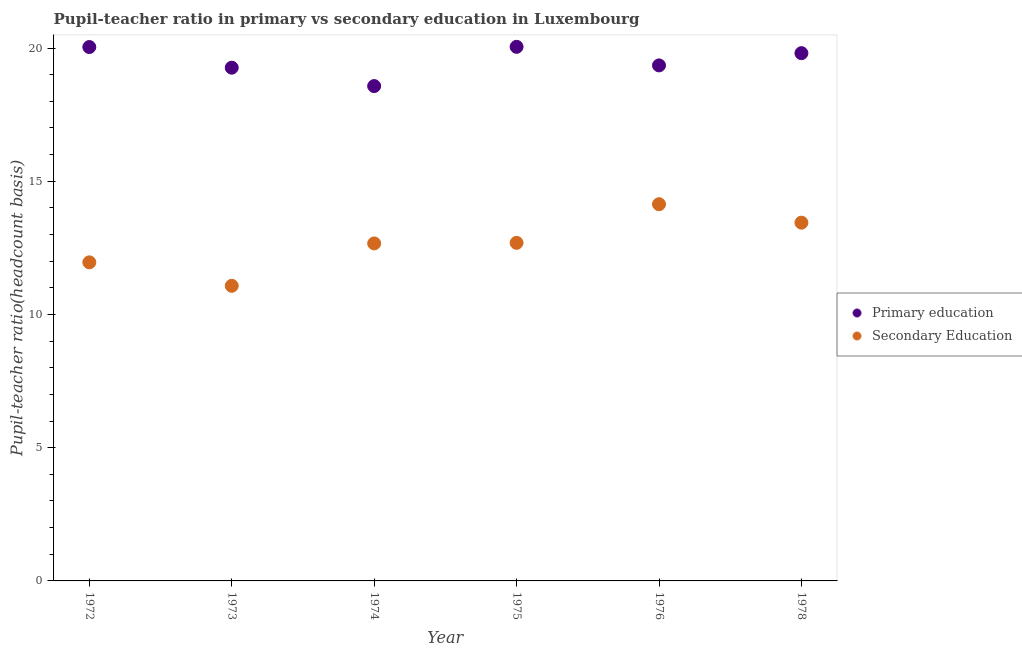Is the number of dotlines equal to the number of legend labels?
Provide a succinct answer. Yes. What is the pupil teacher ratio on secondary education in 1972?
Offer a very short reply. 11.96. Across all years, what is the maximum pupil teacher ratio on secondary education?
Ensure brevity in your answer.  14.14. Across all years, what is the minimum pupil-teacher ratio in primary education?
Offer a terse response. 18.57. In which year was the pupil teacher ratio on secondary education maximum?
Provide a succinct answer. 1976. In which year was the pupil-teacher ratio in primary education minimum?
Offer a terse response. 1974. What is the total pupil-teacher ratio in primary education in the graph?
Your answer should be very brief. 117.08. What is the difference between the pupil teacher ratio on secondary education in 1975 and that in 1976?
Offer a terse response. -1.45. What is the difference between the pupil-teacher ratio in primary education in 1978 and the pupil teacher ratio on secondary education in 1976?
Give a very brief answer. 5.67. What is the average pupil teacher ratio on secondary education per year?
Ensure brevity in your answer.  12.66. In the year 1976, what is the difference between the pupil teacher ratio on secondary education and pupil-teacher ratio in primary education?
Give a very brief answer. -5.21. In how many years, is the pupil teacher ratio on secondary education greater than 7?
Make the answer very short. 6. What is the ratio of the pupil-teacher ratio in primary education in 1972 to that in 1975?
Ensure brevity in your answer.  1. Is the difference between the pupil-teacher ratio in primary education in 1975 and 1976 greater than the difference between the pupil teacher ratio on secondary education in 1975 and 1976?
Your answer should be compact. Yes. What is the difference between the highest and the second highest pupil teacher ratio on secondary education?
Offer a terse response. 0.69. What is the difference between the highest and the lowest pupil teacher ratio on secondary education?
Offer a very short reply. 3.06. Does the pupil-teacher ratio in primary education monotonically increase over the years?
Keep it short and to the point. No. Is the pupil-teacher ratio in primary education strictly greater than the pupil teacher ratio on secondary education over the years?
Give a very brief answer. Yes. Is the pupil teacher ratio on secondary education strictly less than the pupil-teacher ratio in primary education over the years?
Offer a terse response. Yes. How many dotlines are there?
Make the answer very short. 2. Are the values on the major ticks of Y-axis written in scientific E-notation?
Ensure brevity in your answer.  No. Does the graph contain any zero values?
Keep it short and to the point. No. What is the title of the graph?
Ensure brevity in your answer.  Pupil-teacher ratio in primary vs secondary education in Luxembourg. Does "Unregistered firms" appear as one of the legend labels in the graph?
Provide a short and direct response. No. What is the label or title of the X-axis?
Offer a very short reply. Year. What is the label or title of the Y-axis?
Provide a short and direct response. Pupil-teacher ratio(headcount basis). What is the Pupil-teacher ratio(headcount basis) in Primary education in 1972?
Offer a terse response. 20.04. What is the Pupil-teacher ratio(headcount basis) in Secondary Education in 1972?
Provide a succinct answer. 11.96. What is the Pupil-teacher ratio(headcount basis) in Primary education in 1973?
Ensure brevity in your answer.  19.26. What is the Pupil-teacher ratio(headcount basis) of Secondary Education in 1973?
Offer a very short reply. 11.08. What is the Pupil-teacher ratio(headcount basis) in Primary education in 1974?
Provide a short and direct response. 18.57. What is the Pupil-teacher ratio(headcount basis) of Secondary Education in 1974?
Provide a succinct answer. 12.67. What is the Pupil-teacher ratio(headcount basis) in Primary education in 1975?
Provide a succinct answer. 20.05. What is the Pupil-teacher ratio(headcount basis) of Secondary Education in 1975?
Offer a terse response. 12.69. What is the Pupil-teacher ratio(headcount basis) of Primary education in 1976?
Provide a short and direct response. 19.35. What is the Pupil-teacher ratio(headcount basis) of Secondary Education in 1976?
Keep it short and to the point. 14.14. What is the Pupil-teacher ratio(headcount basis) in Primary education in 1978?
Make the answer very short. 19.81. What is the Pupil-teacher ratio(headcount basis) in Secondary Education in 1978?
Your answer should be compact. 13.45. Across all years, what is the maximum Pupil-teacher ratio(headcount basis) of Primary education?
Ensure brevity in your answer.  20.05. Across all years, what is the maximum Pupil-teacher ratio(headcount basis) in Secondary Education?
Your response must be concise. 14.14. Across all years, what is the minimum Pupil-teacher ratio(headcount basis) of Primary education?
Make the answer very short. 18.57. Across all years, what is the minimum Pupil-teacher ratio(headcount basis) of Secondary Education?
Your response must be concise. 11.08. What is the total Pupil-teacher ratio(headcount basis) of Primary education in the graph?
Offer a terse response. 117.08. What is the total Pupil-teacher ratio(headcount basis) of Secondary Education in the graph?
Offer a very short reply. 75.98. What is the difference between the Pupil-teacher ratio(headcount basis) in Primary education in 1972 and that in 1973?
Your answer should be compact. 0.78. What is the difference between the Pupil-teacher ratio(headcount basis) of Secondary Education in 1972 and that in 1973?
Offer a terse response. 0.88. What is the difference between the Pupil-teacher ratio(headcount basis) of Primary education in 1972 and that in 1974?
Your answer should be compact. 1.47. What is the difference between the Pupil-teacher ratio(headcount basis) in Secondary Education in 1972 and that in 1974?
Your answer should be very brief. -0.71. What is the difference between the Pupil-teacher ratio(headcount basis) of Primary education in 1972 and that in 1975?
Your answer should be very brief. -0.01. What is the difference between the Pupil-teacher ratio(headcount basis) of Secondary Education in 1972 and that in 1975?
Provide a short and direct response. -0.73. What is the difference between the Pupil-teacher ratio(headcount basis) of Primary education in 1972 and that in 1976?
Provide a succinct answer. 0.69. What is the difference between the Pupil-teacher ratio(headcount basis) of Secondary Education in 1972 and that in 1976?
Offer a terse response. -2.18. What is the difference between the Pupil-teacher ratio(headcount basis) of Primary education in 1972 and that in 1978?
Ensure brevity in your answer.  0.23. What is the difference between the Pupil-teacher ratio(headcount basis) of Secondary Education in 1972 and that in 1978?
Make the answer very short. -1.49. What is the difference between the Pupil-teacher ratio(headcount basis) of Primary education in 1973 and that in 1974?
Your answer should be very brief. 0.69. What is the difference between the Pupil-teacher ratio(headcount basis) of Secondary Education in 1973 and that in 1974?
Keep it short and to the point. -1.59. What is the difference between the Pupil-teacher ratio(headcount basis) in Primary education in 1973 and that in 1975?
Keep it short and to the point. -0.78. What is the difference between the Pupil-teacher ratio(headcount basis) of Secondary Education in 1973 and that in 1975?
Give a very brief answer. -1.61. What is the difference between the Pupil-teacher ratio(headcount basis) of Primary education in 1973 and that in 1976?
Give a very brief answer. -0.09. What is the difference between the Pupil-teacher ratio(headcount basis) in Secondary Education in 1973 and that in 1976?
Your answer should be compact. -3.06. What is the difference between the Pupil-teacher ratio(headcount basis) in Primary education in 1973 and that in 1978?
Provide a short and direct response. -0.55. What is the difference between the Pupil-teacher ratio(headcount basis) of Secondary Education in 1973 and that in 1978?
Offer a terse response. -2.37. What is the difference between the Pupil-teacher ratio(headcount basis) of Primary education in 1974 and that in 1975?
Offer a very short reply. -1.47. What is the difference between the Pupil-teacher ratio(headcount basis) of Secondary Education in 1974 and that in 1975?
Make the answer very short. -0.02. What is the difference between the Pupil-teacher ratio(headcount basis) of Primary education in 1974 and that in 1976?
Your answer should be compact. -0.78. What is the difference between the Pupil-teacher ratio(headcount basis) of Secondary Education in 1974 and that in 1976?
Your response must be concise. -1.47. What is the difference between the Pupil-teacher ratio(headcount basis) of Primary education in 1974 and that in 1978?
Your answer should be very brief. -1.24. What is the difference between the Pupil-teacher ratio(headcount basis) of Secondary Education in 1974 and that in 1978?
Make the answer very short. -0.78. What is the difference between the Pupil-teacher ratio(headcount basis) in Primary education in 1975 and that in 1976?
Provide a short and direct response. 0.7. What is the difference between the Pupil-teacher ratio(headcount basis) in Secondary Education in 1975 and that in 1976?
Your answer should be compact. -1.45. What is the difference between the Pupil-teacher ratio(headcount basis) in Primary education in 1975 and that in 1978?
Ensure brevity in your answer.  0.24. What is the difference between the Pupil-teacher ratio(headcount basis) of Secondary Education in 1975 and that in 1978?
Provide a succinct answer. -0.76. What is the difference between the Pupil-teacher ratio(headcount basis) of Primary education in 1976 and that in 1978?
Your answer should be very brief. -0.46. What is the difference between the Pupil-teacher ratio(headcount basis) of Secondary Education in 1976 and that in 1978?
Ensure brevity in your answer.  0.69. What is the difference between the Pupil-teacher ratio(headcount basis) in Primary education in 1972 and the Pupil-teacher ratio(headcount basis) in Secondary Education in 1973?
Ensure brevity in your answer.  8.96. What is the difference between the Pupil-teacher ratio(headcount basis) of Primary education in 1972 and the Pupil-teacher ratio(headcount basis) of Secondary Education in 1974?
Give a very brief answer. 7.37. What is the difference between the Pupil-teacher ratio(headcount basis) in Primary education in 1972 and the Pupil-teacher ratio(headcount basis) in Secondary Education in 1975?
Offer a very short reply. 7.35. What is the difference between the Pupil-teacher ratio(headcount basis) in Primary education in 1972 and the Pupil-teacher ratio(headcount basis) in Secondary Education in 1976?
Keep it short and to the point. 5.9. What is the difference between the Pupil-teacher ratio(headcount basis) of Primary education in 1972 and the Pupil-teacher ratio(headcount basis) of Secondary Education in 1978?
Give a very brief answer. 6.59. What is the difference between the Pupil-teacher ratio(headcount basis) in Primary education in 1973 and the Pupil-teacher ratio(headcount basis) in Secondary Education in 1974?
Ensure brevity in your answer.  6.6. What is the difference between the Pupil-teacher ratio(headcount basis) of Primary education in 1973 and the Pupil-teacher ratio(headcount basis) of Secondary Education in 1975?
Your response must be concise. 6.57. What is the difference between the Pupil-teacher ratio(headcount basis) of Primary education in 1973 and the Pupil-teacher ratio(headcount basis) of Secondary Education in 1976?
Keep it short and to the point. 5.12. What is the difference between the Pupil-teacher ratio(headcount basis) of Primary education in 1973 and the Pupil-teacher ratio(headcount basis) of Secondary Education in 1978?
Your response must be concise. 5.82. What is the difference between the Pupil-teacher ratio(headcount basis) in Primary education in 1974 and the Pupil-teacher ratio(headcount basis) in Secondary Education in 1975?
Make the answer very short. 5.88. What is the difference between the Pupil-teacher ratio(headcount basis) of Primary education in 1974 and the Pupil-teacher ratio(headcount basis) of Secondary Education in 1976?
Keep it short and to the point. 4.43. What is the difference between the Pupil-teacher ratio(headcount basis) of Primary education in 1974 and the Pupil-teacher ratio(headcount basis) of Secondary Education in 1978?
Give a very brief answer. 5.13. What is the difference between the Pupil-teacher ratio(headcount basis) in Primary education in 1975 and the Pupil-teacher ratio(headcount basis) in Secondary Education in 1976?
Give a very brief answer. 5.91. What is the difference between the Pupil-teacher ratio(headcount basis) in Primary education in 1975 and the Pupil-teacher ratio(headcount basis) in Secondary Education in 1978?
Make the answer very short. 6.6. What is the difference between the Pupil-teacher ratio(headcount basis) in Primary education in 1976 and the Pupil-teacher ratio(headcount basis) in Secondary Education in 1978?
Make the answer very short. 5.9. What is the average Pupil-teacher ratio(headcount basis) in Primary education per year?
Offer a terse response. 19.51. What is the average Pupil-teacher ratio(headcount basis) in Secondary Education per year?
Make the answer very short. 12.66. In the year 1972, what is the difference between the Pupil-teacher ratio(headcount basis) of Primary education and Pupil-teacher ratio(headcount basis) of Secondary Education?
Your answer should be very brief. 8.08. In the year 1973, what is the difference between the Pupil-teacher ratio(headcount basis) of Primary education and Pupil-teacher ratio(headcount basis) of Secondary Education?
Keep it short and to the point. 8.19. In the year 1974, what is the difference between the Pupil-teacher ratio(headcount basis) in Primary education and Pupil-teacher ratio(headcount basis) in Secondary Education?
Ensure brevity in your answer.  5.91. In the year 1975, what is the difference between the Pupil-teacher ratio(headcount basis) in Primary education and Pupil-teacher ratio(headcount basis) in Secondary Education?
Provide a short and direct response. 7.36. In the year 1976, what is the difference between the Pupil-teacher ratio(headcount basis) in Primary education and Pupil-teacher ratio(headcount basis) in Secondary Education?
Offer a terse response. 5.21. In the year 1978, what is the difference between the Pupil-teacher ratio(headcount basis) in Primary education and Pupil-teacher ratio(headcount basis) in Secondary Education?
Your answer should be compact. 6.36. What is the ratio of the Pupil-teacher ratio(headcount basis) of Primary education in 1972 to that in 1973?
Offer a terse response. 1.04. What is the ratio of the Pupil-teacher ratio(headcount basis) of Secondary Education in 1972 to that in 1973?
Offer a terse response. 1.08. What is the ratio of the Pupil-teacher ratio(headcount basis) of Primary education in 1972 to that in 1974?
Your answer should be compact. 1.08. What is the ratio of the Pupil-teacher ratio(headcount basis) of Secondary Education in 1972 to that in 1974?
Your answer should be very brief. 0.94. What is the ratio of the Pupil-teacher ratio(headcount basis) of Secondary Education in 1972 to that in 1975?
Ensure brevity in your answer.  0.94. What is the ratio of the Pupil-teacher ratio(headcount basis) of Primary education in 1972 to that in 1976?
Make the answer very short. 1.04. What is the ratio of the Pupil-teacher ratio(headcount basis) of Secondary Education in 1972 to that in 1976?
Give a very brief answer. 0.85. What is the ratio of the Pupil-teacher ratio(headcount basis) of Primary education in 1972 to that in 1978?
Offer a terse response. 1.01. What is the ratio of the Pupil-teacher ratio(headcount basis) in Secondary Education in 1972 to that in 1978?
Provide a short and direct response. 0.89. What is the ratio of the Pupil-teacher ratio(headcount basis) in Primary education in 1973 to that in 1974?
Your answer should be compact. 1.04. What is the ratio of the Pupil-teacher ratio(headcount basis) in Secondary Education in 1973 to that in 1974?
Make the answer very short. 0.87. What is the ratio of the Pupil-teacher ratio(headcount basis) of Primary education in 1973 to that in 1975?
Make the answer very short. 0.96. What is the ratio of the Pupil-teacher ratio(headcount basis) of Secondary Education in 1973 to that in 1975?
Your response must be concise. 0.87. What is the ratio of the Pupil-teacher ratio(headcount basis) of Primary education in 1973 to that in 1976?
Your answer should be very brief. 1. What is the ratio of the Pupil-teacher ratio(headcount basis) of Secondary Education in 1973 to that in 1976?
Provide a succinct answer. 0.78. What is the ratio of the Pupil-teacher ratio(headcount basis) in Primary education in 1973 to that in 1978?
Provide a succinct answer. 0.97. What is the ratio of the Pupil-teacher ratio(headcount basis) in Secondary Education in 1973 to that in 1978?
Ensure brevity in your answer.  0.82. What is the ratio of the Pupil-teacher ratio(headcount basis) in Primary education in 1974 to that in 1975?
Offer a very short reply. 0.93. What is the ratio of the Pupil-teacher ratio(headcount basis) of Primary education in 1974 to that in 1976?
Your answer should be compact. 0.96. What is the ratio of the Pupil-teacher ratio(headcount basis) in Secondary Education in 1974 to that in 1976?
Make the answer very short. 0.9. What is the ratio of the Pupil-teacher ratio(headcount basis) of Primary education in 1974 to that in 1978?
Offer a very short reply. 0.94. What is the ratio of the Pupil-teacher ratio(headcount basis) in Secondary Education in 1974 to that in 1978?
Provide a succinct answer. 0.94. What is the ratio of the Pupil-teacher ratio(headcount basis) of Primary education in 1975 to that in 1976?
Offer a terse response. 1.04. What is the ratio of the Pupil-teacher ratio(headcount basis) of Secondary Education in 1975 to that in 1976?
Offer a very short reply. 0.9. What is the ratio of the Pupil-teacher ratio(headcount basis) in Primary education in 1975 to that in 1978?
Your answer should be very brief. 1.01. What is the ratio of the Pupil-teacher ratio(headcount basis) of Secondary Education in 1975 to that in 1978?
Give a very brief answer. 0.94. What is the ratio of the Pupil-teacher ratio(headcount basis) of Primary education in 1976 to that in 1978?
Give a very brief answer. 0.98. What is the ratio of the Pupil-teacher ratio(headcount basis) in Secondary Education in 1976 to that in 1978?
Make the answer very short. 1.05. What is the difference between the highest and the second highest Pupil-teacher ratio(headcount basis) in Primary education?
Ensure brevity in your answer.  0.01. What is the difference between the highest and the second highest Pupil-teacher ratio(headcount basis) of Secondary Education?
Ensure brevity in your answer.  0.69. What is the difference between the highest and the lowest Pupil-teacher ratio(headcount basis) of Primary education?
Your response must be concise. 1.47. What is the difference between the highest and the lowest Pupil-teacher ratio(headcount basis) in Secondary Education?
Keep it short and to the point. 3.06. 